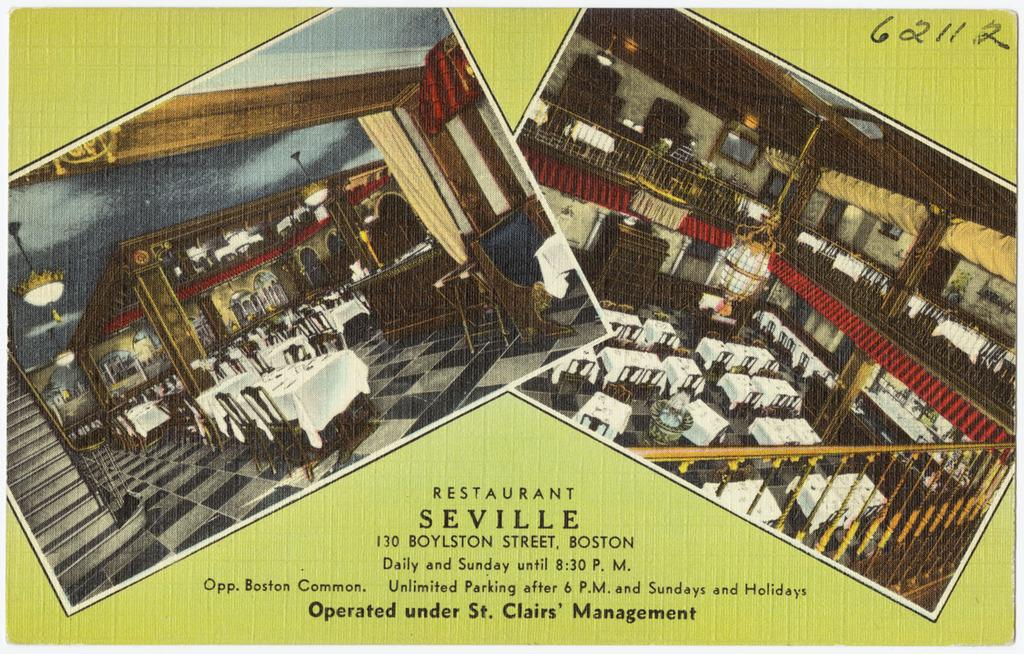<image>
Write a terse but informative summary of the picture. Two old pictures of the restaurant Seville in Boston 